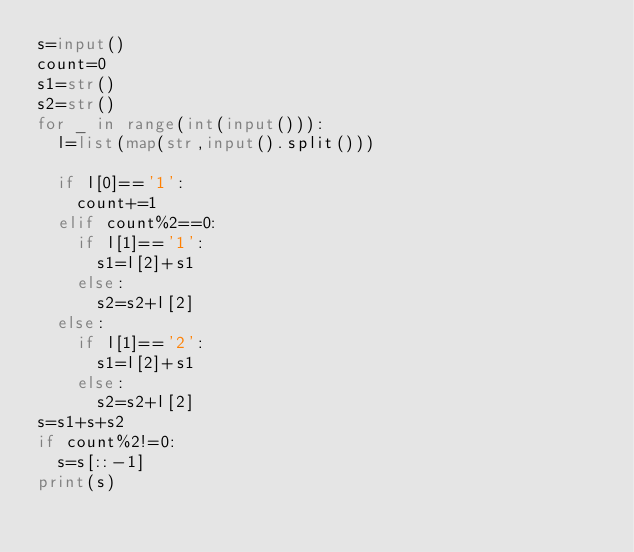<code> <loc_0><loc_0><loc_500><loc_500><_Python_>s=input()
count=0
s1=str()
s2=str()
for _ in range(int(input())):
  l=list(map(str,input().split()))
  
  if l[0]=='1':
    count+=1
  elif count%2==0:
    if l[1]=='1':
      s1=l[2]+s1
    else:
      s2=s2+l[2]
  else:
    if l[1]=='2':
      s1=l[2]+s1
    else:
      s2=s2+l[2]
s=s1+s+s2
if count%2!=0:
  s=s[::-1]
print(s)</code> 